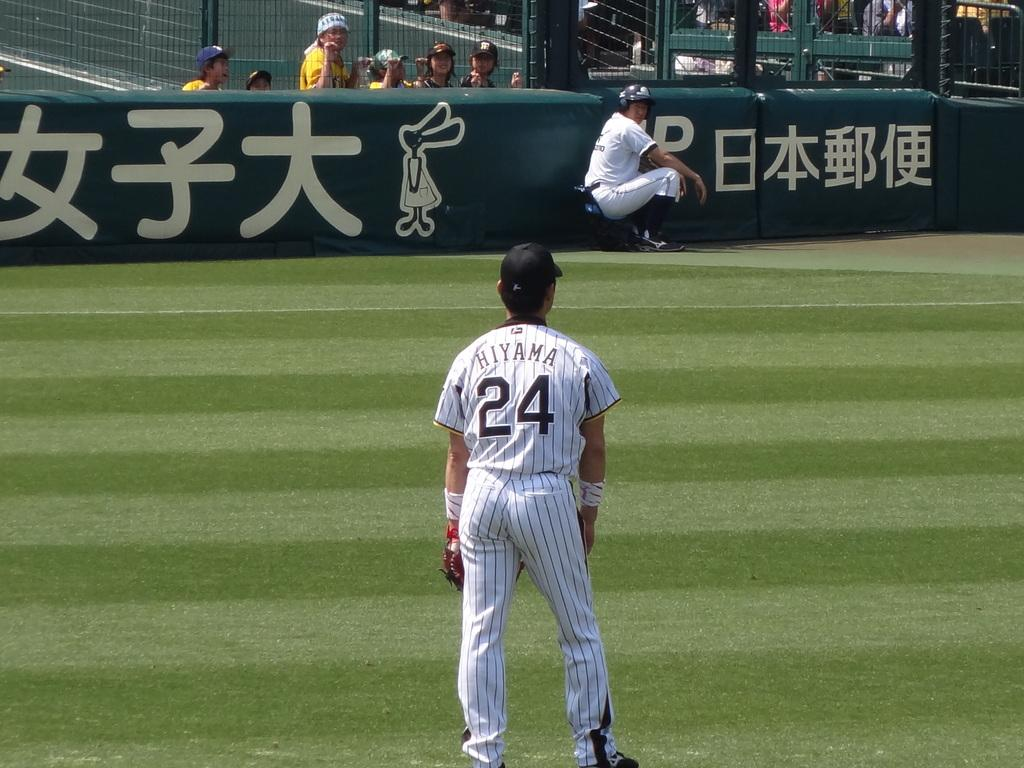<image>
Render a clear and concise summary of the photo. A man with the name Hiyama on his jersey stands on a baseball field. 